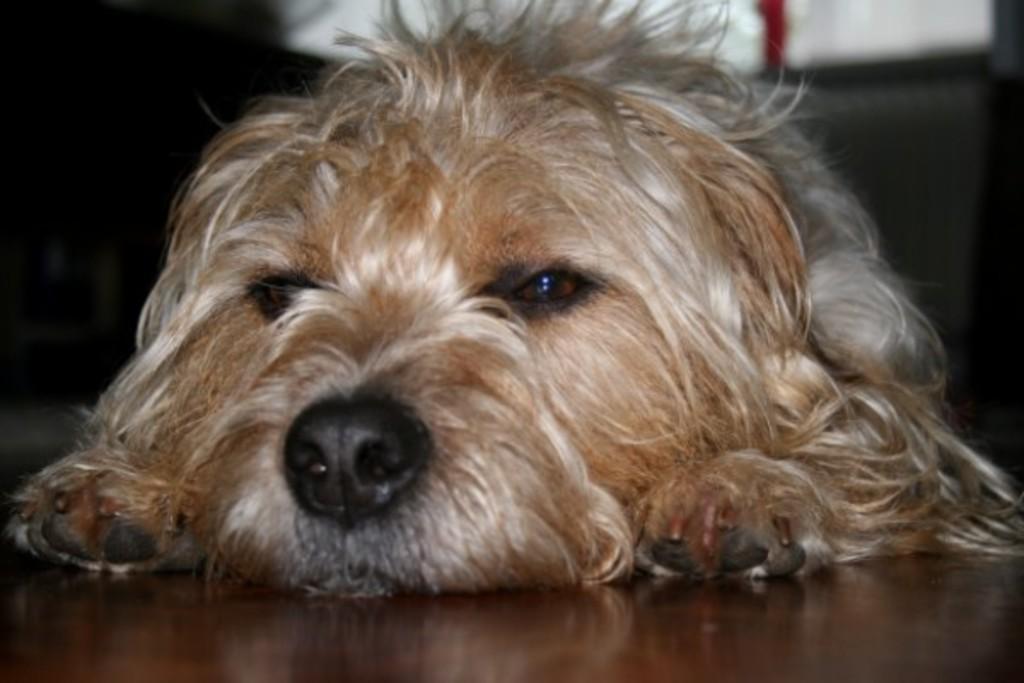Can you describe this image briefly? In the image we can see there is a dog lying on the floor and background of the image is little blurred. 